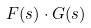Convert formula to latex. <formula><loc_0><loc_0><loc_500><loc_500>F ( s ) \cdot G ( s )</formula> 